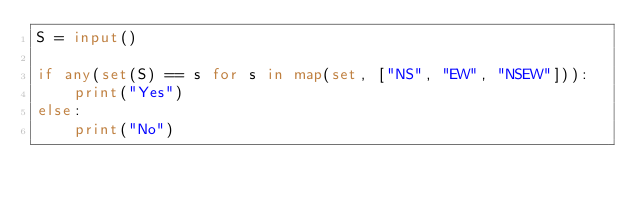<code> <loc_0><loc_0><loc_500><loc_500><_Python_>S = input()

if any(set(S) == s for s in map(set, ["NS", "EW", "NSEW"])):
    print("Yes")
else:
    print("No")
</code> 